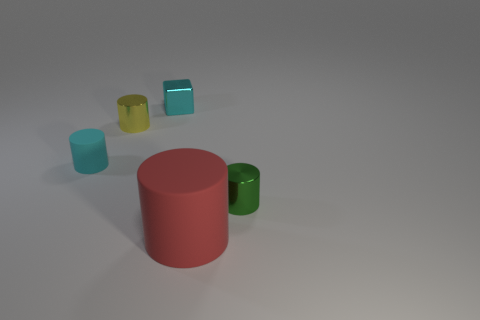Is the number of tiny yellow cylinders to the right of the small rubber cylinder greater than the number of small green shiny cylinders on the right side of the tiny green metal object?
Your answer should be compact. Yes. Is the shape of the matte object on the left side of the cyan metal block the same as the cyan thing behind the tiny cyan matte cylinder?
Ensure brevity in your answer.  No. How many other things are there of the same size as the red cylinder?
Offer a very short reply. 0. What is the size of the green cylinder?
Keep it short and to the point. Small. Does the small yellow object behind the green metal cylinder have the same material as the tiny green object?
Make the answer very short. Yes. There is another matte object that is the same shape as the cyan matte object; what color is it?
Keep it short and to the point. Red. There is a matte thing that is to the left of the large matte cylinder; does it have the same color as the tiny cube?
Provide a succinct answer. Yes. Are there any tiny cyan objects right of the large red rubber object?
Your answer should be compact. No. There is a small cylinder that is both behind the green metal object and on the right side of the tiny cyan cylinder; what is its color?
Keep it short and to the point. Yellow. What shape is the small rubber thing that is the same color as the tiny cube?
Ensure brevity in your answer.  Cylinder. 